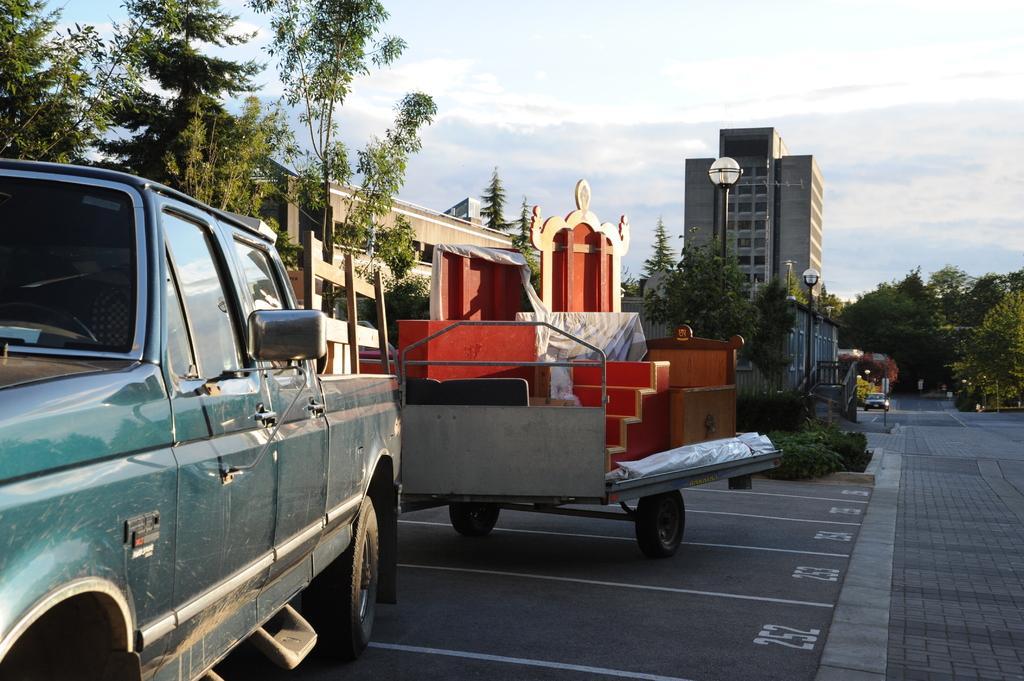Please provide a concise description of this image. This is an outside view. On the left side there are two vehicles on the road. In the background there are many trees and buildings. Beside the road there are light poles. On the right side there is a car on the road. At the top of the image I can see the sky. 